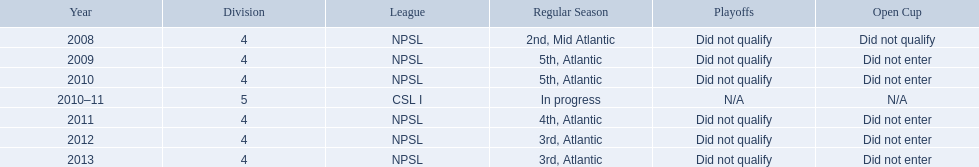What are the leagues? NPSL, NPSL, NPSL, CSL I, NPSL, NPSL, NPSL. Of these, what league is not npsl? CSL I. Can you provide the names of the leagues? NPSL, CSL I. Which league, apart from npsl, has the ny soccer team competed in? CSL I. 